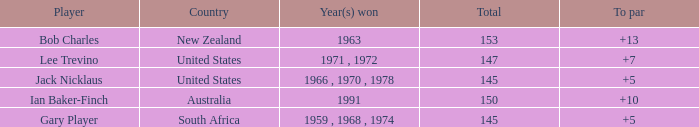What is the lowest To par of gary player, with more than 145 total? None. 